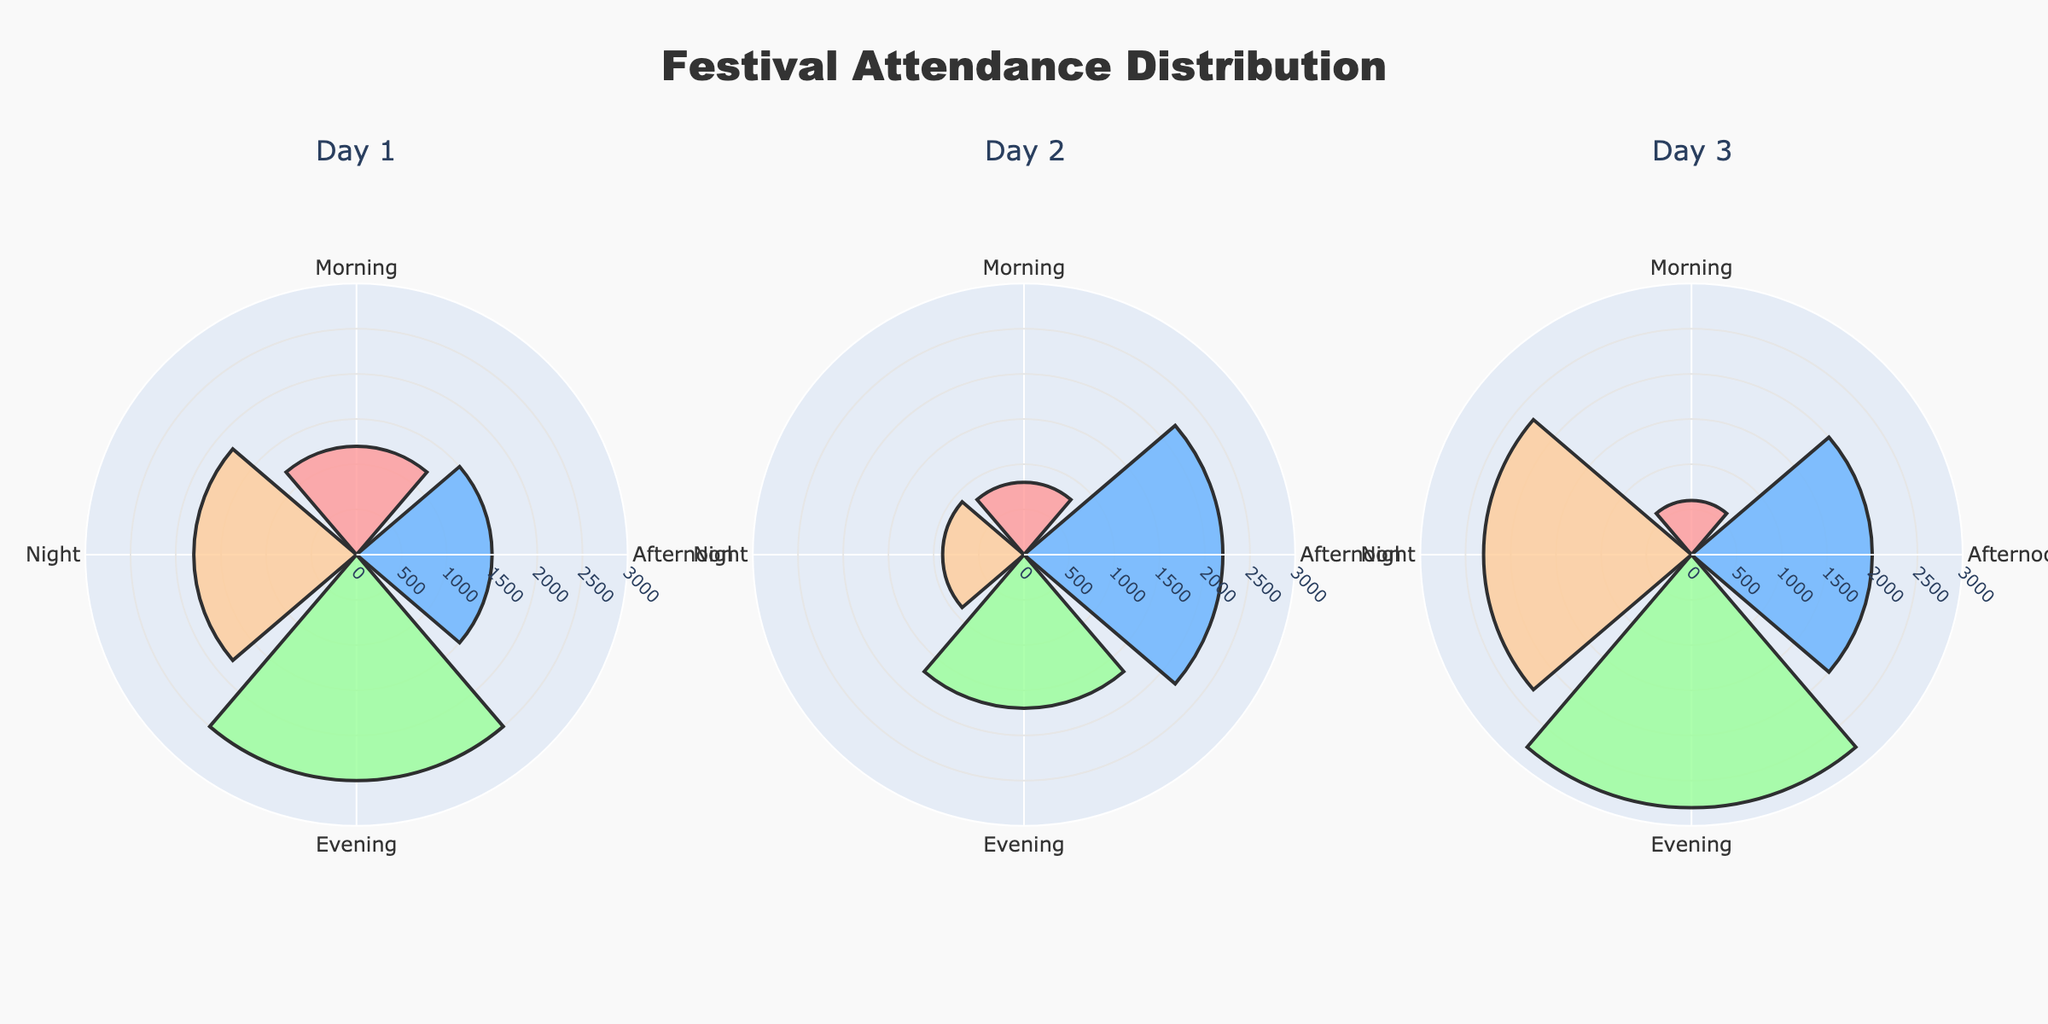What's the title of the plot? The title is typically located at the top center of the plot. Here, it reads "Festival Attendance Distribution".
Answer: Festival Attendance Distribution How many festival days are shown in the plot? Each subplot title represents a different day. There are three subplots shown, labeled as "Day 1", "Day 2", "Day 3".
Answer: 3 Which day had the highest evening attendance? Look at the evening slots in each subplot. The attendance in the evening of Day 3 (which features Concert - Pop Stars) is the highest with 2800 attendees.
Answer: Day 3 What's the average morning attendance over the three days? The morning attendance for each day is: Day 1 = 1200, Day 2 = 800, Day 3 = 600. The average is (1200 + 800 + 600) / 3 = 866.7.
Answer: 866.7 Which event had the lowest attendance, and when did it occur? Scan each subplot for the smallest radius bar. The Workshop - Local Crafts on the morning of Day 3 had the lowest attendance with 600 attendees.
Answer: Workshop - Local Crafts, Day 3 Morning How does the attendance of the Food Fair on Day 2 compare to the Street Parade on Day 1? Check the length of the bars for Food Fair on Day 2 and Street Parade on Day 1. The Food Fair on Day 2 had 2200 attendees, and the Street Parade on Day 1 had 1500 attendees. So, the Food Fair had higher attendance.
Answer: Food Fair had higher attendance What is the total attendance for concerts across all three days? Summing the attendance of each concert: Day 1 Evening (2500) + Day 2 Evening (1700) + Day 3 Evening (2800) = 7000.
Answer: 7000 Which night event had the highest attendance? Compare the night segment of each day. The Fireworks on Day 1 had the highest attendance at night with 1800 attendees.
Answer: Fireworks on Day 1 